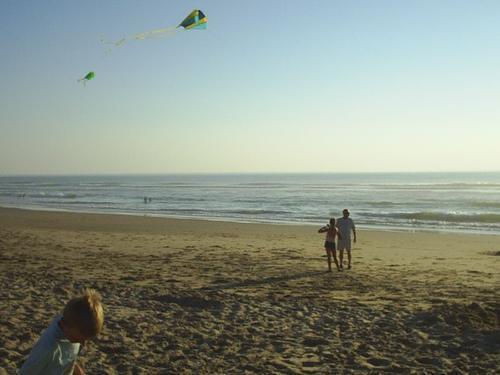How many kites are flying?
Give a very brief answer. 2. 